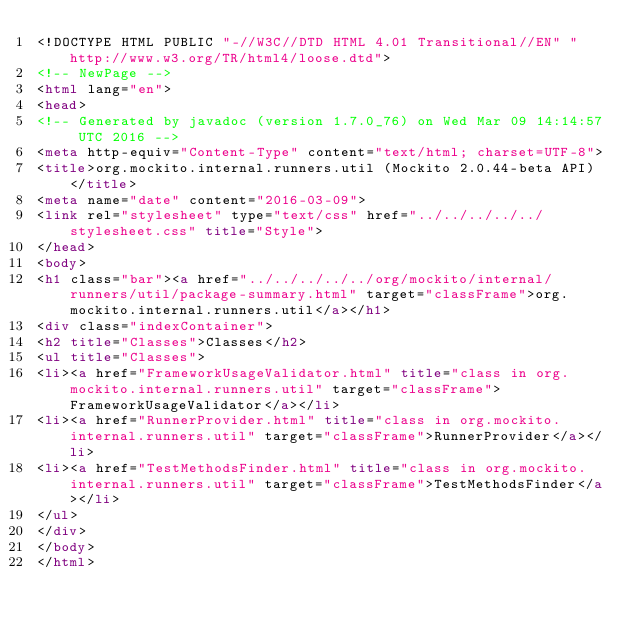<code> <loc_0><loc_0><loc_500><loc_500><_HTML_><!DOCTYPE HTML PUBLIC "-//W3C//DTD HTML 4.01 Transitional//EN" "http://www.w3.org/TR/html4/loose.dtd">
<!-- NewPage -->
<html lang="en">
<head>
<!-- Generated by javadoc (version 1.7.0_76) on Wed Mar 09 14:14:57 UTC 2016 -->
<meta http-equiv="Content-Type" content="text/html; charset=UTF-8">
<title>org.mockito.internal.runners.util (Mockito 2.0.44-beta API)</title>
<meta name="date" content="2016-03-09">
<link rel="stylesheet" type="text/css" href="../../../../../stylesheet.css" title="Style">
</head>
<body>
<h1 class="bar"><a href="../../../../../org/mockito/internal/runners/util/package-summary.html" target="classFrame">org.mockito.internal.runners.util</a></h1>
<div class="indexContainer">
<h2 title="Classes">Classes</h2>
<ul title="Classes">
<li><a href="FrameworkUsageValidator.html" title="class in org.mockito.internal.runners.util" target="classFrame">FrameworkUsageValidator</a></li>
<li><a href="RunnerProvider.html" title="class in org.mockito.internal.runners.util" target="classFrame">RunnerProvider</a></li>
<li><a href="TestMethodsFinder.html" title="class in org.mockito.internal.runners.util" target="classFrame">TestMethodsFinder</a></li>
</ul>
</div>
</body>
</html>
</code> 